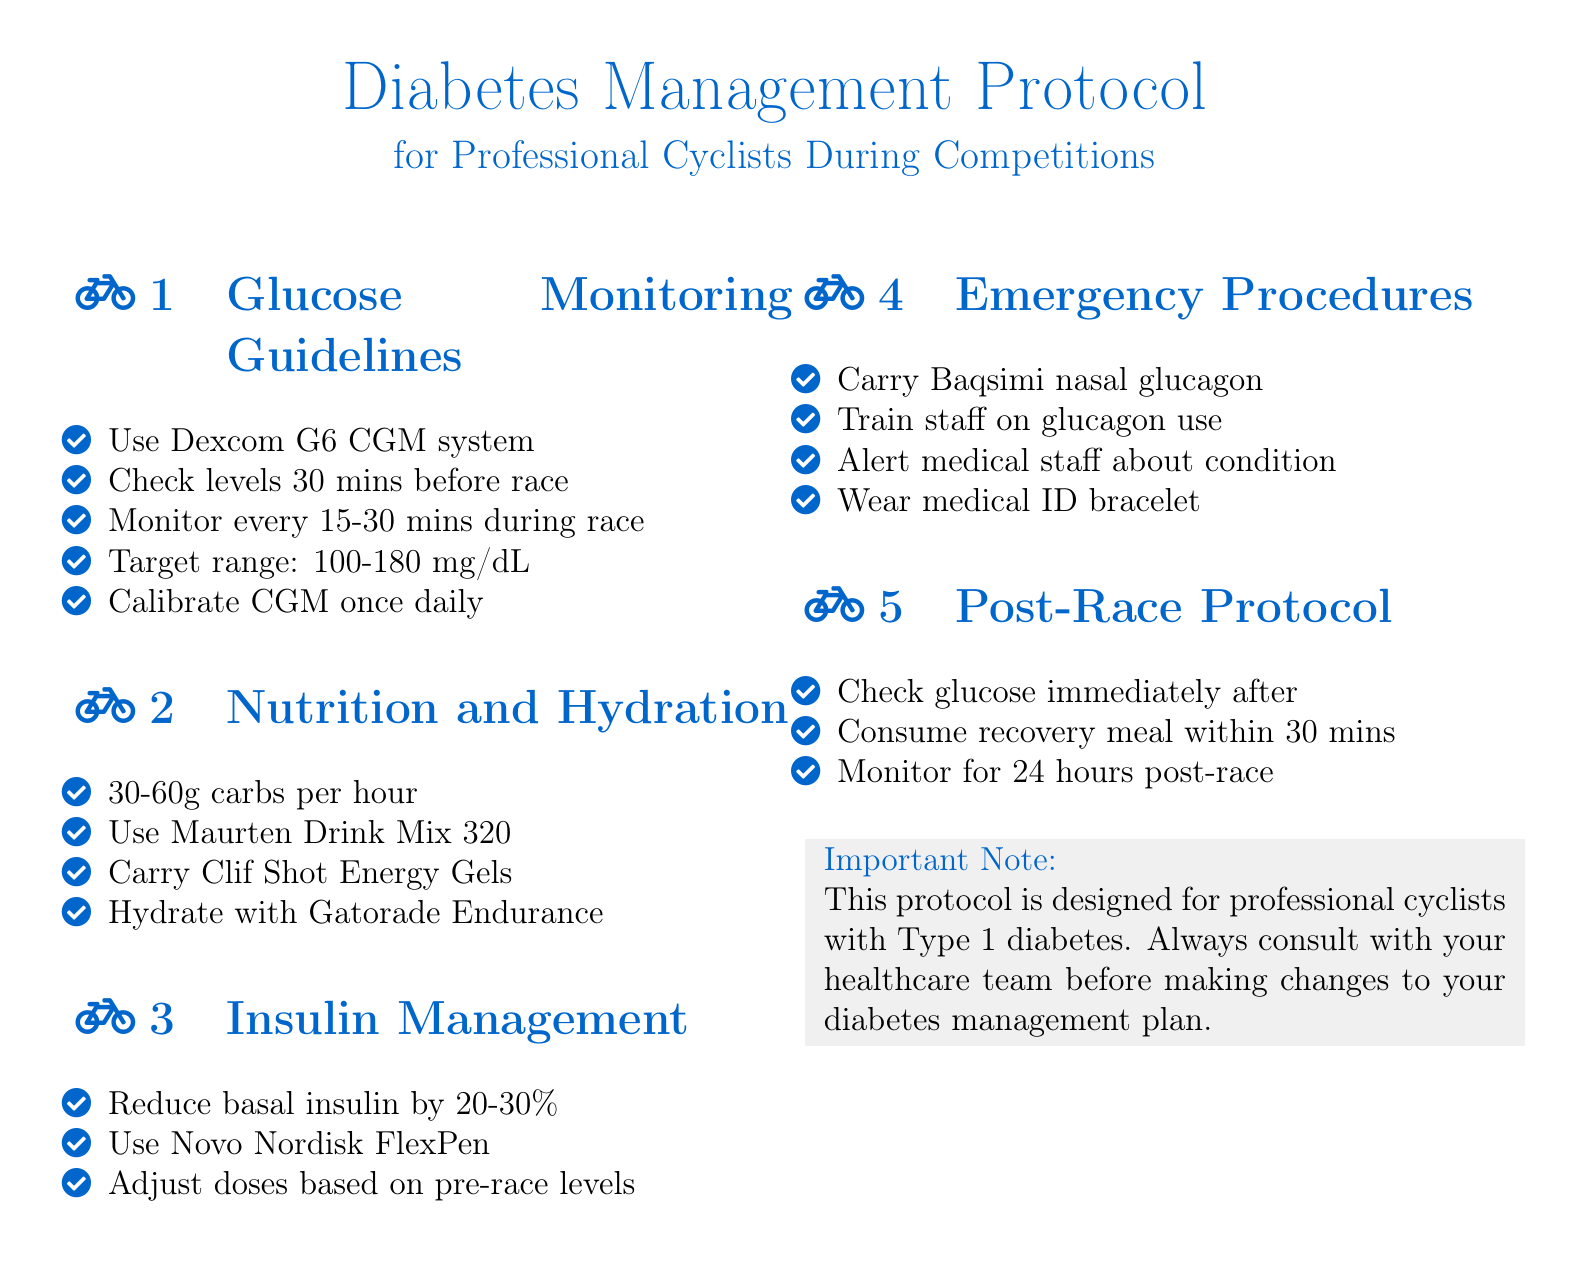what is the target glucose range? The target glucose range is specifically mentioned in the guidelines section of the document.
Answer: 100-180 mg/dL how often should glucose levels be monitored during a race? The document states the frequency of glucose monitoring during the race.
Answer: Every 15-30 minutes what is the recommended carbohydrate intake per hour? This information is provided in the nutrition and hydration section of the document.
Answer: 30-60g carbs what type of glucagon should be carried during competitions? This is mentioned in the emergency procedures section.
Answer: Baqsimi nasal glucagon how soon should a recovery meal be consumed after a race? The document specifies the timing for the recovery meal.
Answer: Within 30 minutes what percentage reduction is advised for basal insulin? The specific percentage reduction for basal insulin is included in the insulin management section.
Answer: 20-30% how often should the CGM be calibrated? This detail is found in the glucose monitoring guidelines.
Answer: Once daily what drink mix is recommended for hydration? The specific drink mix suggested for hydration is detailed in the nutrition section.
Answer: Maurten Drink Mix 320 